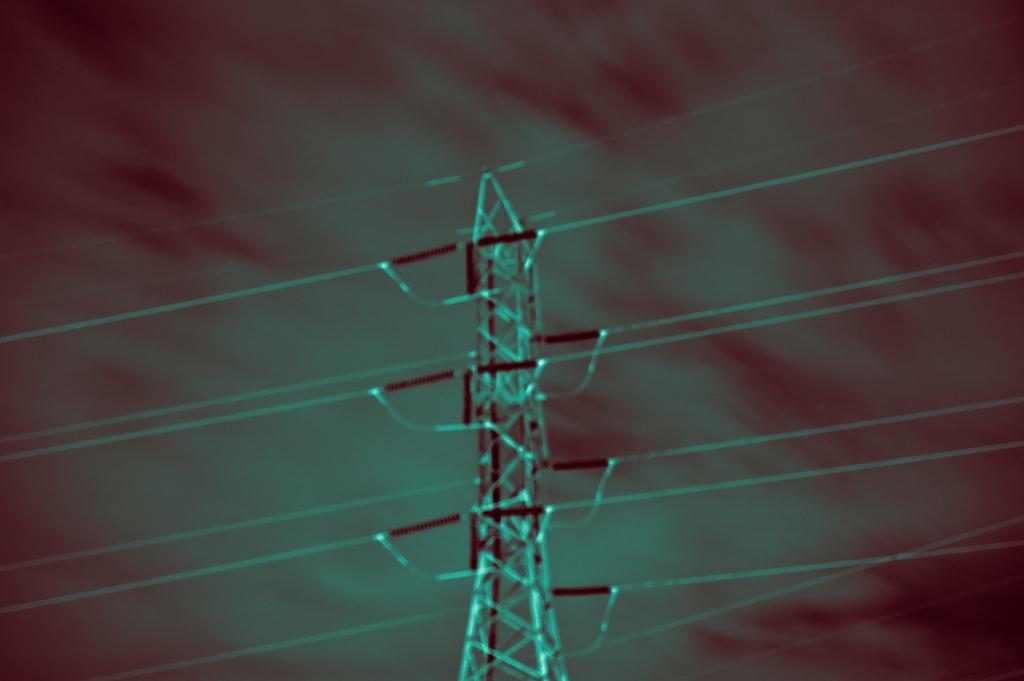What is the main structure visible in the image? There is an electric tower in the image. What is connected to the electric tower? There are wires attached to the electric tower. What is the condition of the sky in the image? The sky is covered with clouds in the image. Can you tell me what the argument is about in the image? There is no argument present in the image; it features an electric tower with wires and a cloudy sky. What type of wrist accessory is visible on someone's wrist in the image? There are no people or wrist accessories present in the image. 